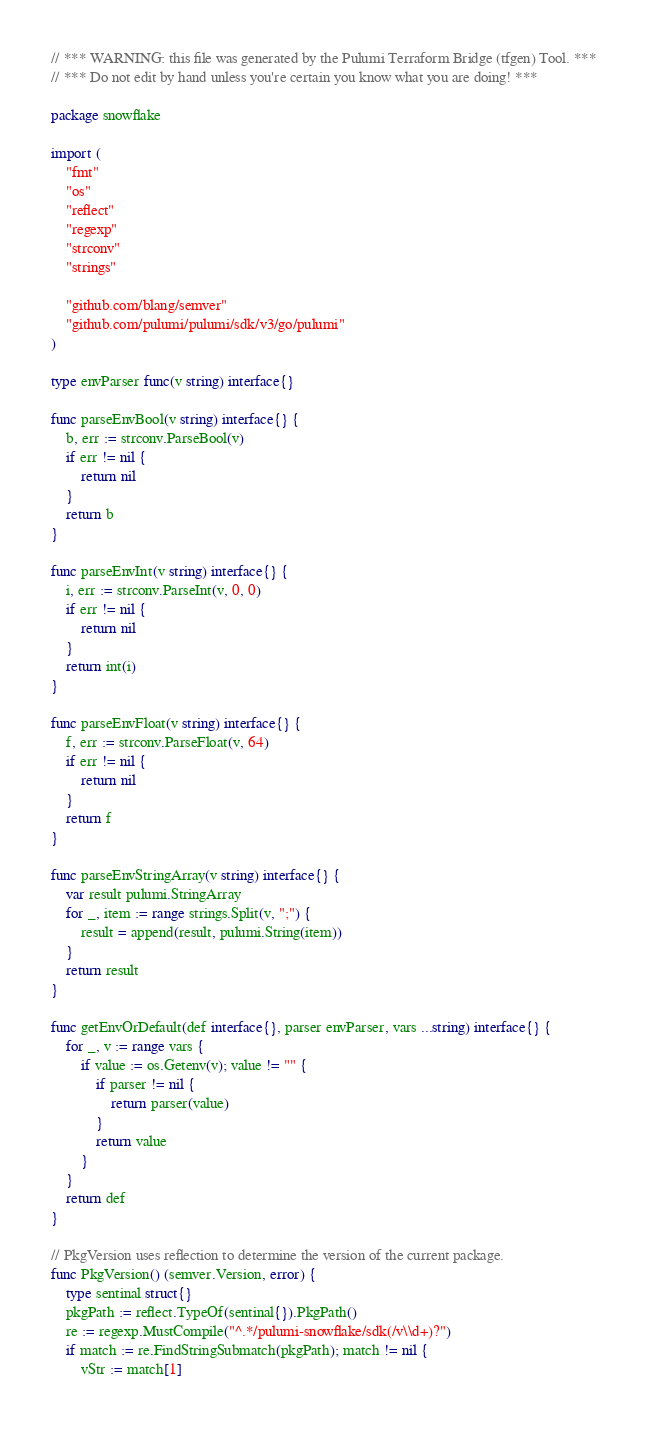<code> <loc_0><loc_0><loc_500><loc_500><_Go_>// *** WARNING: this file was generated by the Pulumi Terraform Bridge (tfgen) Tool. ***
// *** Do not edit by hand unless you're certain you know what you are doing! ***

package snowflake

import (
	"fmt"
	"os"
	"reflect"
	"regexp"
	"strconv"
	"strings"

	"github.com/blang/semver"
	"github.com/pulumi/pulumi/sdk/v3/go/pulumi"
)

type envParser func(v string) interface{}

func parseEnvBool(v string) interface{} {
	b, err := strconv.ParseBool(v)
	if err != nil {
		return nil
	}
	return b
}

func parseEnvInt(v string) interface{} {
	i, err := strconv.ParseInt(v, 0, 0)
	if err != nil {
		return nil
	}
	return int(i)
}

func parseEnvFloat(v string) interface{} {
	f, err := strconv.ParseFloat(v, 64)
	if err != nil {
		return nil
	}
	return f
}

func parseEnvStringArray(v string) interface{} {
	var result pulumi.StringArray
	for _, item := range strings.Split(v, ";") {
		result = append(result, pulumi.String(item))
	}
	return result
}

func getEnvOrDefault(def interface{}, parser envParser, vars ...string) interface{} {
	for _, v := range vars {
		if value := os.Getenv(v); value != "" {
			if parser != nil {
				return parser(value)
			}
			return value
		}
	}
	return def
}

// PkgVersion uses reflection to determine the version of the current package.
func PkgVersion() (semver.Version, error) {
	type sentinal struct{}
	pkgPath := reflect.TypeOf(sentinal{}).PkgPath()
	re := regexp.MustCompile("^.*/pulumi-snowflake/sdk(/v\\d+)?")
	if match := re.FindStringSubmatch(pkgPath); match != nil {
		vStr := match[1]</code> 